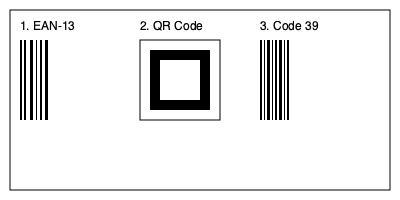Which of the barcodes shown is most commonly used for ISBN (International Standard Book Number) encoding in library cataloguing systems? To determine which barcode is most commonly used for ISBN encoding in library cataloguing systems, let's analyze each option:

1. EAN-13 (European Article Number-13):
   - This is the most common barcode used for ISBN encoding in libraries.
   - It consists of 13 digits, which perfectly accommodates the 13-digit ISBN format.
   - EAN-13 is widely used in book publishing and library systems worldwide.

2. QR Code (Quick Response Code):
   - While QR codes are increasingly used in libraries for various purposes, they are not the primary choice for ISBN encoding.
   - QR codes can store more information but are typically used for linking to digital resources or providing additional information about a book.

3. Code 39:
   - Code 39 is an older barcode symbology that can encode alphanumeric characters.
   - While it can be used to encode ISBNs, it is less common in modern library systems compared to EAN-13.
   - Code 39 is more often used for internal library processes or older systems.

Given that the EAN-13 barcode is specifically designed to accommodate the 13-digit ISBN format and is widely adopted in the book industry and library systems, it is the most common choice for ISBN encoding in library cataloguing systems.
Answer: EAN-13 